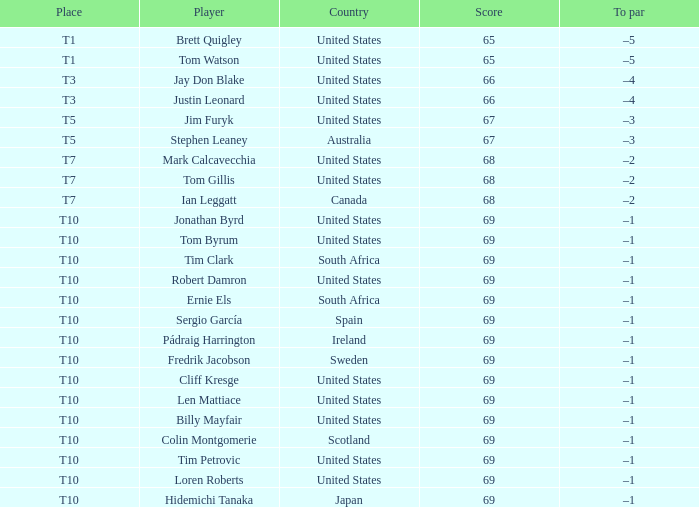What is the typical score of the player ranked t5 in the united states? 67.0. 